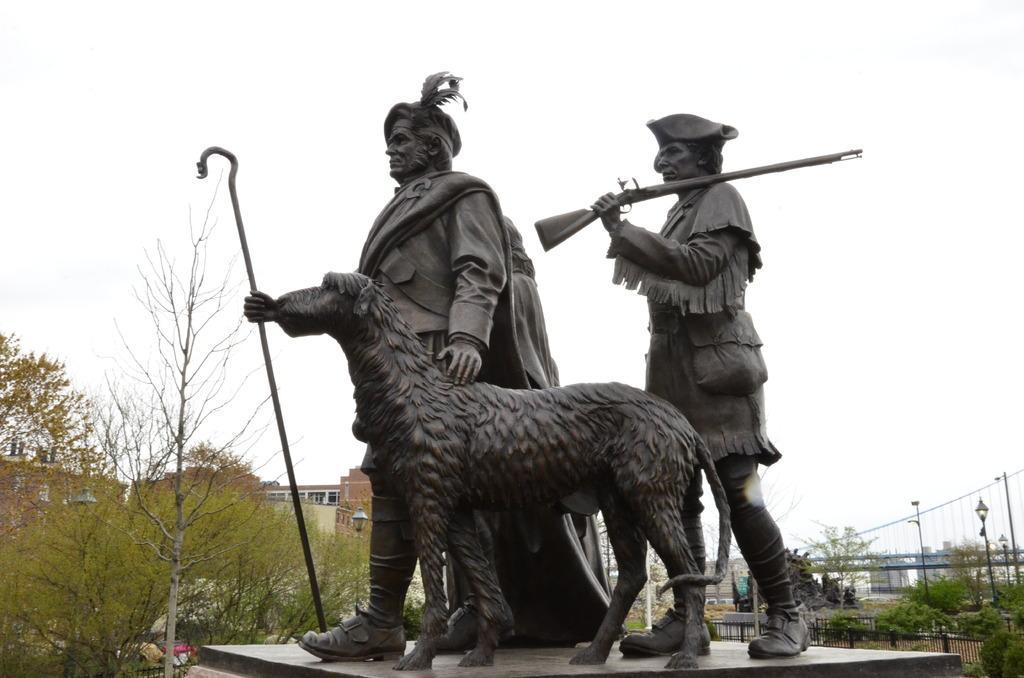Could you give a brief overview of what you see in this image? In the middle there are statues of 2 humans and an animal. On the left side there are trees and houses. At the top it is the sky. 